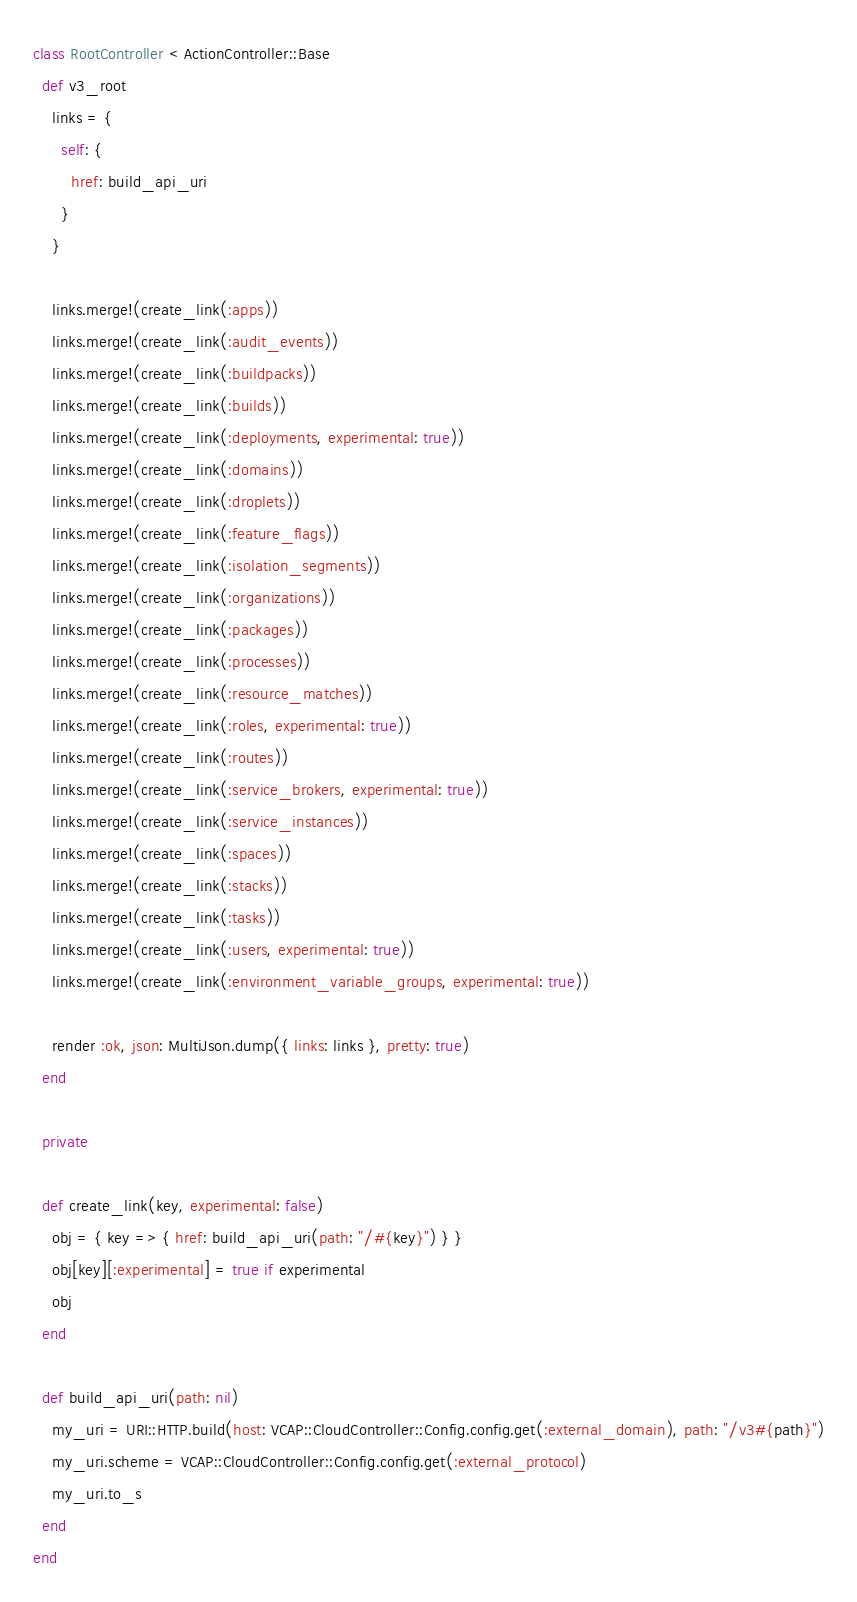Convert code to text. <code><loc_0><loc_0><loc_500><loc_500><_Ruby_>class RootController < ActionController::Base
  def v3_root
    links = {
      self: {
        href: build_api_uri
      }
    }

    links.merge!(create_link(:apps))
    links.merge!(create_link(:audit_events))
    links.merge!(create_link(:buildpacks))
    links.merge!(create_link(:builds))
    links.merge!(create_link(:deployments, experimental: true))
    links.merge!(create_link(:domains))
    links.merge!(create_link(:droplets))
    links.merge!(create_link(:feature_flags))
    links.merge!(create_link(:isolation_segments))
    links.merge!(create_link(:organizations))
    links.merge!(create_link(:packages))
    links.merge!(create_link(:processes))
    links.merge!(create_link(:resource_matches))
    links.merge!(create_link(:roles, experimental: true))
    links.merge!(create_link(:routes))
    links.merge!(create_link(:service_brokers, experimental: true))
    links.merge!(create_link(:service_instances))
    links.merge!(create_link(:spaces))
    links.merge!(create_link(:stacks))
    links.merge!(create_link(:tasks))
    links.merge!(create_link(:users, experimental: true))
    links.merge!(create_link(:environment_variable_groups, experimental: true))

    render :ok, json: MultiJson.dump({ links: links }, pretty: true)
  end

  private

  def create_link(key, experimental: false)
    obj = { key => { href: build_api_uri(path: "/#{key}") } }
    obj[key][:experimental] = true if experimental
    obj
  end

  def build_api_uri(path: nil)
    my_uri = URI::HTTP.build(host: VCAP::CloudController::Config.config.get(:external_domain), path: "/v3#{path}")
    my_uri.scheme = VCAP::CloudController::Config.config.get(:external_protocol)
    my_uri.to_s
  end
end
</code> 